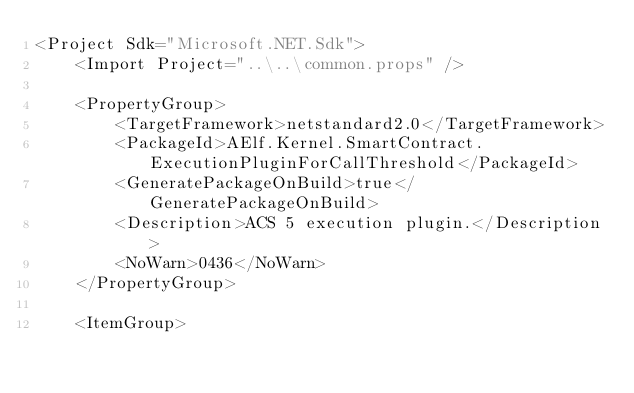Convert code to text. <code><loc_0><loc_0><loc_500><loc_500><_XML_><Project Sdk="Microsoft.NET.Sdk">
    <Import Project="..\..\common.props" />

    <PropertyGroup>
        <TargetFramework>netstandard2.0</TargetFramework>
        <PackageId>AElf.Kernel.SmartContract.ExecutionPluginForCallThreshold</PackageId>
        <GeneratePackageOnBuild>true</GeneratePackageOnBuild>
        <Description>ACS 5 execution plugin.</Description>
        <NoWarn>0436</NoWarn>
    </PropertyGroup>

    <ItemGroup></code> 